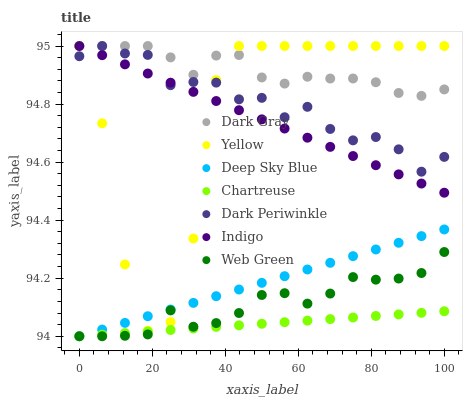Does Chartreuse have the minimum area under the curve?
Answer yes or no. Yes. Does Dark Gray have the maximum area under the curve?
Answer yes or no. Yes. Does Yellow have the minimum area under the curve?
Answer yes or no. No. Does Yellow have the maximum area under the curve?
Answer yes or no. No. Is Deep Sky Blue the smoothest?
Answer yes or no. Yes. Is Yellow the roughest?
Answer yes or no. Yes. Is Dark Gray the smoothest?
Answer yes or no. No. Is Dark Gray the roughest?
Answer yes or no. No. Does Chartreuse have the lowest value?
Answer yes or no. Yes. Does Yellow have the lowest value?
Answer yes or no. No. Does Dark Periwinkle have the highest value?
Answer yes or no. Yes. Does Chartreuse have the highest value?
Answer yes or no. No. Is Deep Sky Blue less than Indigo?
Answer yes or no. Yes. Is Dark Periwinkle greater than Web Green?
Answer yes or no. Yes. Does Indigo intersect Dark Periwinkle?
Answer yes or no. Yes. Is Indigo less than Dark Periwinkle?
Answer yes or no. No. Is Indigo greater than Dark Periwinkle?
Answer yes or no. No. Does Deep Sky Blue intersect Indigo?
Answer yes or no. No. 